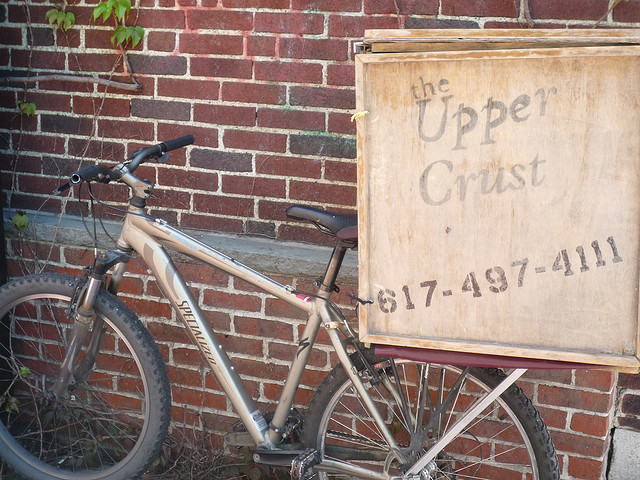Please transcribe the text in this image. the the Upper Crust 4111 497 S SPECIALIZED 617 